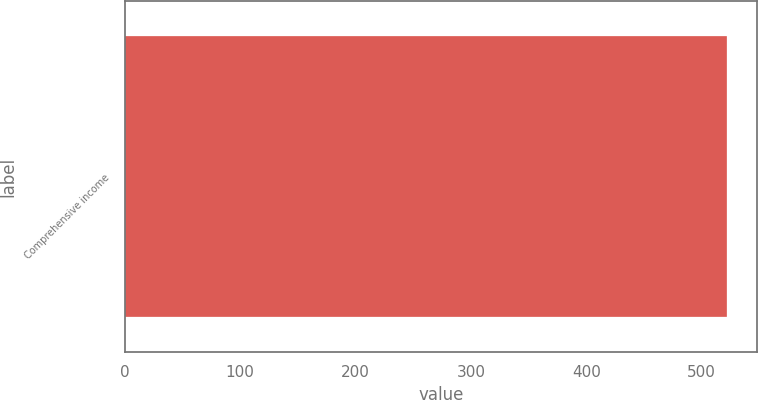<chart> <loc_0><loc_0><loc_500><loc_500><bar_chart><fcel>Comprehensive income<nl><fcel>522.1<nl></chart> 